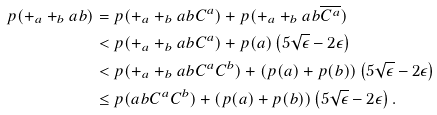Convert formula to latex. <formula><loc_0><loc_0><loc_500><loc_500>p ( + _ { a } + _ { b } a b ) & = p ( + _ { a } + _ { b } a b C ^ { a } ) + p ( + _ { a } + _ { b } a b \overline { C ^ { a } } ) \\ & < p ( + _ { a } + _ { b } a b C ^ { a } ) + p ( a ) \left ( 5 \sqrt { \epsilon } - 2 \epsilon \right ) \\ & < p ( + _ { a } + _ { b } a b C ^ { a } C ^ { b } ) + \left ( p ( a ) + p ( b ) \right ) \left ( 5 \sqrt { \epsilon } - 2 \epsilon \right ) \\ & \leq p ( a b C ^ { a } C ^ { b } ) + \left ( p ( a ) + p ( b ) \right ) \left ( 5 \sqrt { \epsilon } - 2 \epsilon \right ) .</formula> 